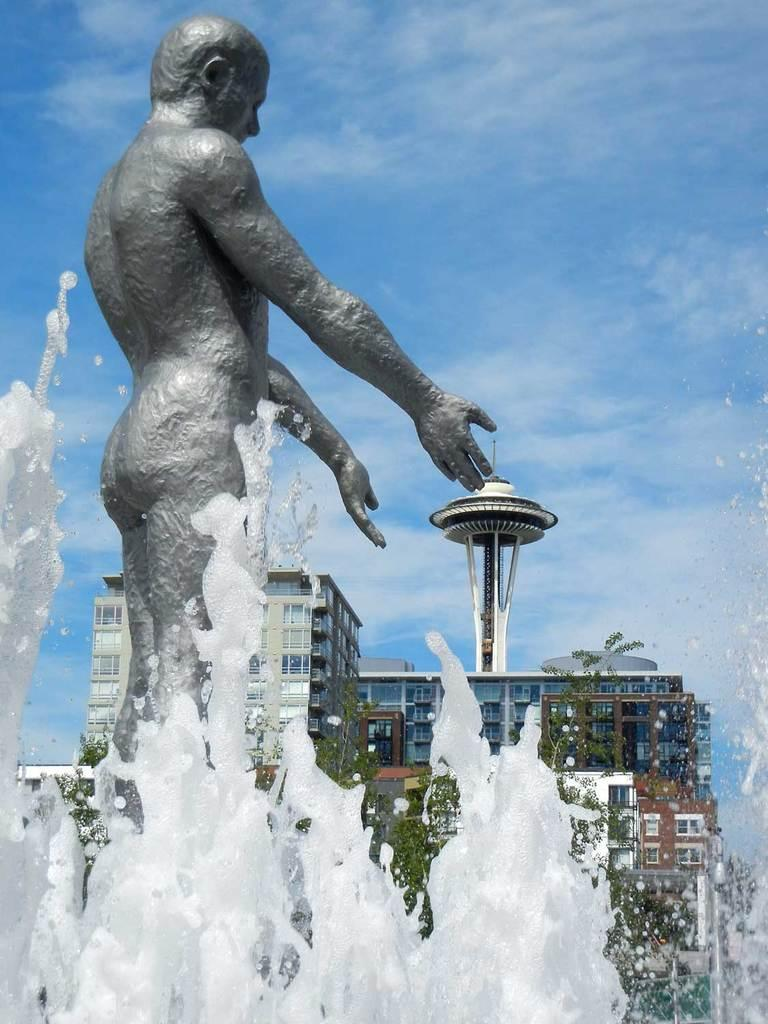What can be seen in the sky in the image? The sky is visible in the image, and there are clouds in the sky. What type of structures are present in the image? There are buildings and a tower in the image. What type of vegetation is present in the image? There are trees in the image. What type of artwork is present in the image? There is a sculptor in the image. What type of water feature is present in the image? There is a fountain in the image. What type of poison is being used by the doll in the image? There is no doll or poison present in the image. 